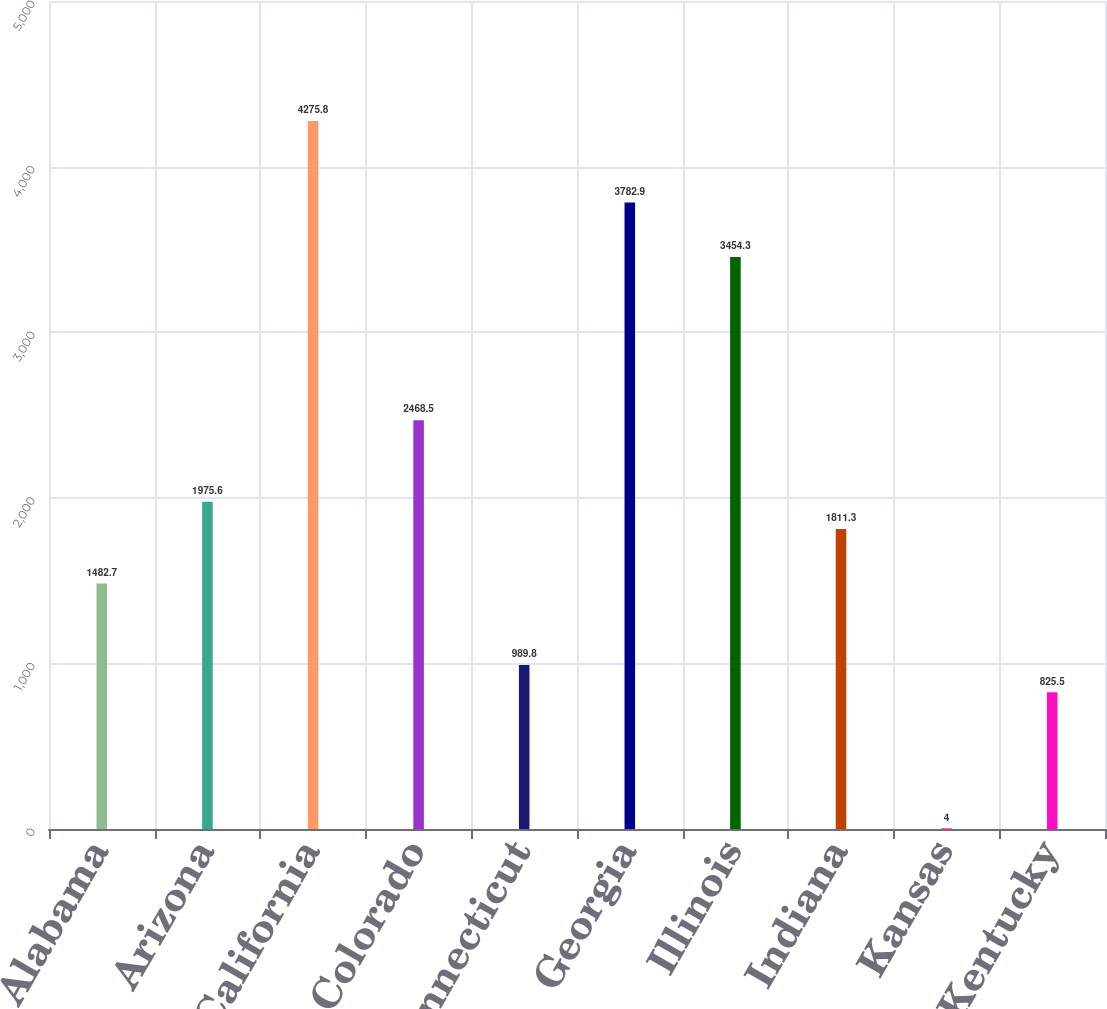<chart> <loc_0><loc_0><loc_500><loc_500><bar_chart><fcel>Alabama<fcel>Arizona<fcel>California<fcel>Colorado<fcel>Connecticut<fcel>Georgia<fcel>Illinois<fcel>Indiana<fcel>Kansas<fcel>Kentucky<nl><fcel>1482.7<fcel>1975.6<fcel>4275.8<fcel>2468.5<fcel>989.8<fcel>3782.9<fcel>3454.3<fcel>1811.3<fcel>4<fcel>825.5<nl></chart> 